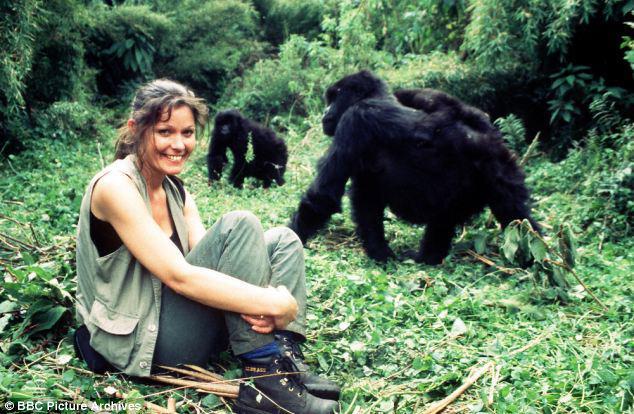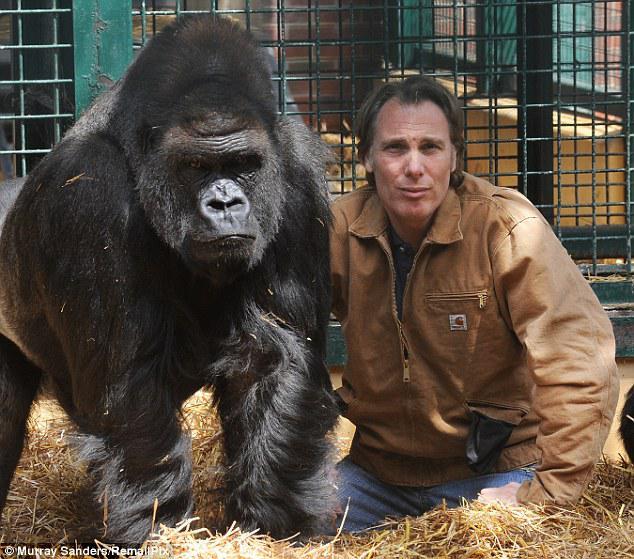The first image is the image on the left, the second image is the image on the right. Given the left and right images, does the statement "There are exactly three animals." hold true? Answer yes or no. No. The first image is the image on the left, the second image is the image on the right. Examine the images to the left and right. Is the description "An image shows at least one forward-facing gorilla with something stick-like in its mouth." accurate? Answer yes or no. No. 